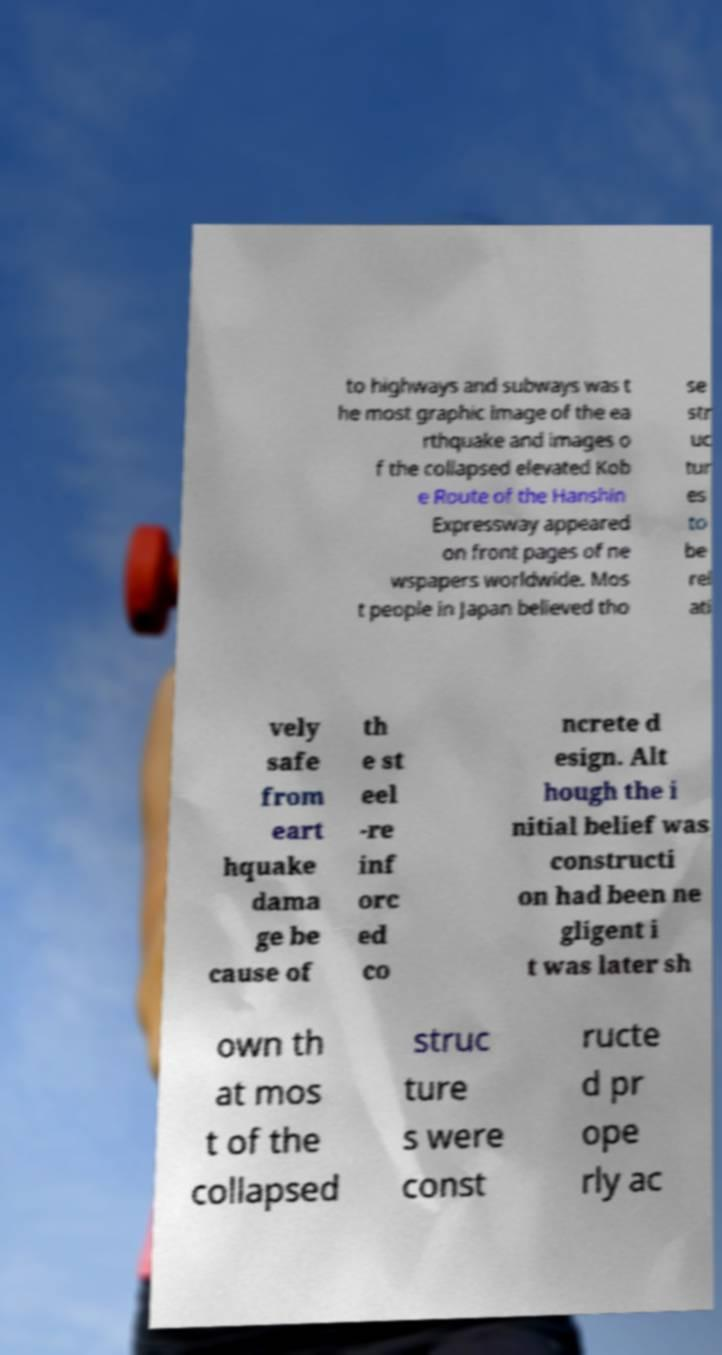Can you accurately transcribe the text from the provided image for me? to highways and subways was t he most graphic image of the ea rthquake and images o f the collapsed elevated Kob e Route of the Hanshin Expressway appeared on front pages of ne wspapers worldwide. Mos t people in Japan believed tho se str uc tur es to be rel ati vely safe from eart hquake dama ge be cause of th e st eel -re inf orc ed co ncrete d esign. Alt hough the i nitial belief was constructi on had been ne gligent i t was later sh own th at mos t of the collapsed struc ture s were const ructe d pr ope rly ac 